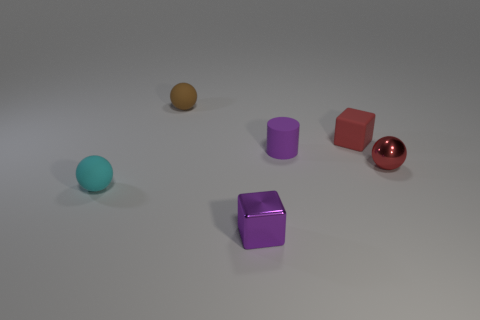Which objects in the image have reflective surfaces? The objects with reflective surfaces in the image are the red cube and the purple cylinder. Their surfaces are shiny, indicating that they reflect the light in the environment, giving a mirror-like appearance. 